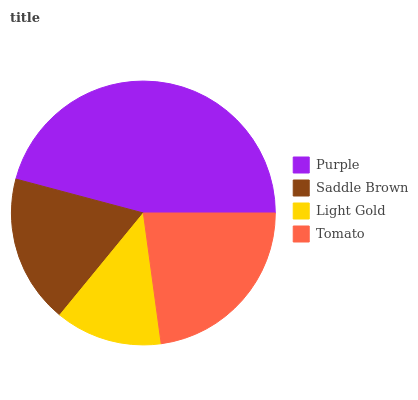Is Light Gold the minimum?
Answer yes or no. Yes. Is Purple the maximum?
Answer yes or no. Yes. Is Saddle Brown the minimum?
Answer yes or no. No. Is Saddle Brown the maximum?
Answer yes or no. No. Is Purple greater than Saddle Brown?
Answer yes or no. Yes. Is Saddle Brown less than Purple?
Answer yes or no. Yes. Is Saddle Brown greater than Purple?
Answer yes or no. No. Is Purple less than Saddle Brown?
Answer yes or no. No. Is Tomato the high median?
Answer yes or no. Yes. Is Saddle Brown the low median?
Answer yes or no. Yes. Is Saddle Brown the high median?
Answer yes or no. No. Is Light Gold the low median?
Answer yes or no. No. 